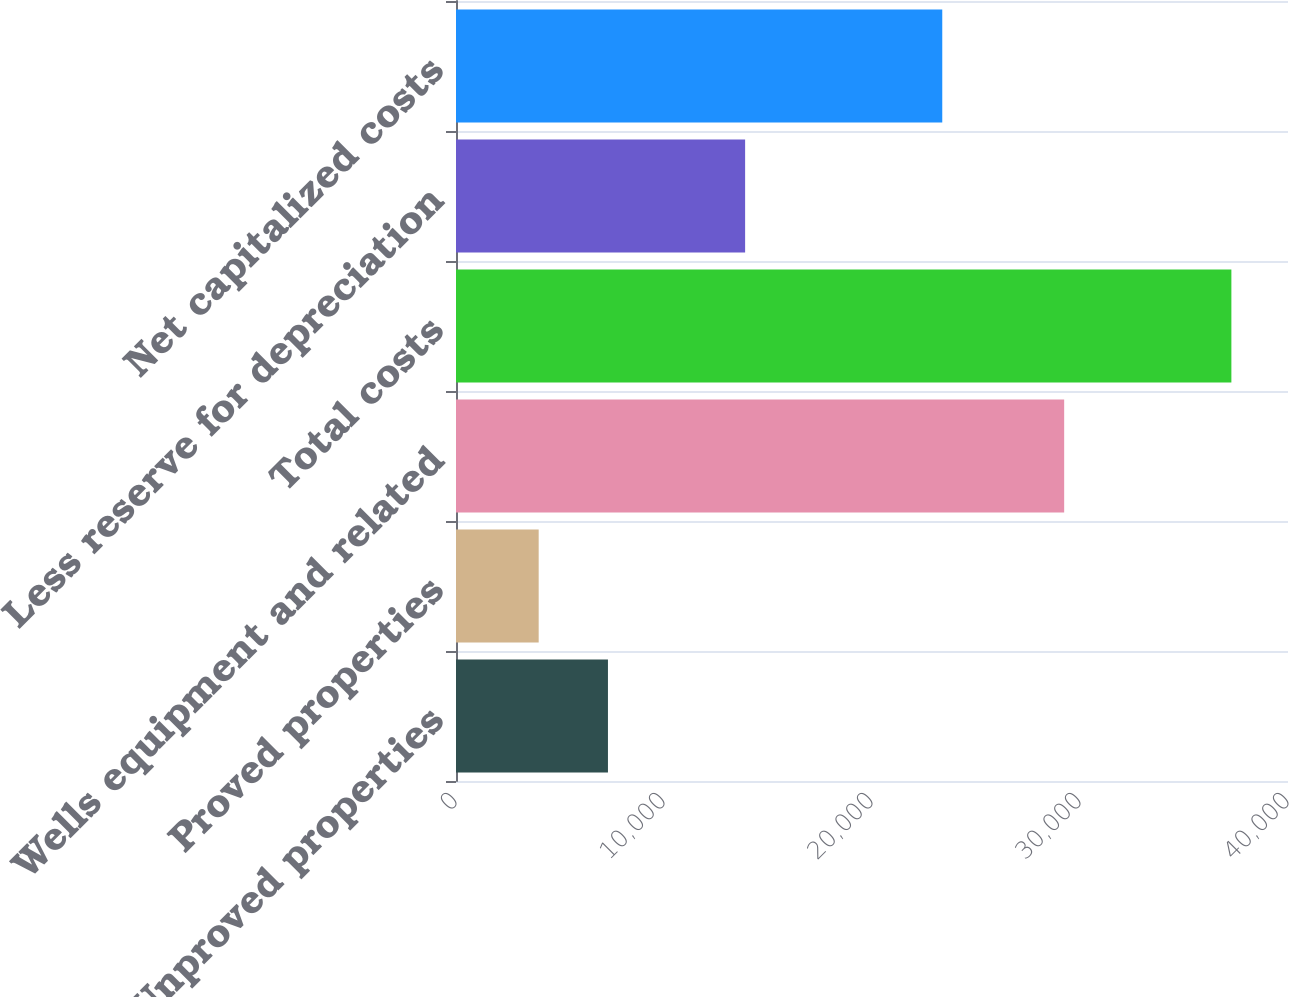Convert chart to OTSL. <chart><loc_0><loc_0><loc_500><loc_500><bar_chart><fcel>Unproved properties<fcel>Proved properties<fcel>Wells equipment and related<fcel>Total costs<fcel>Less reserve for depreciation<fcel>Net capitalized costs<nl><fcel>7305.3<fcel>3975<fcel>29239<fcel>37278<fcel>13900<fcel>23378<nl></chart> 